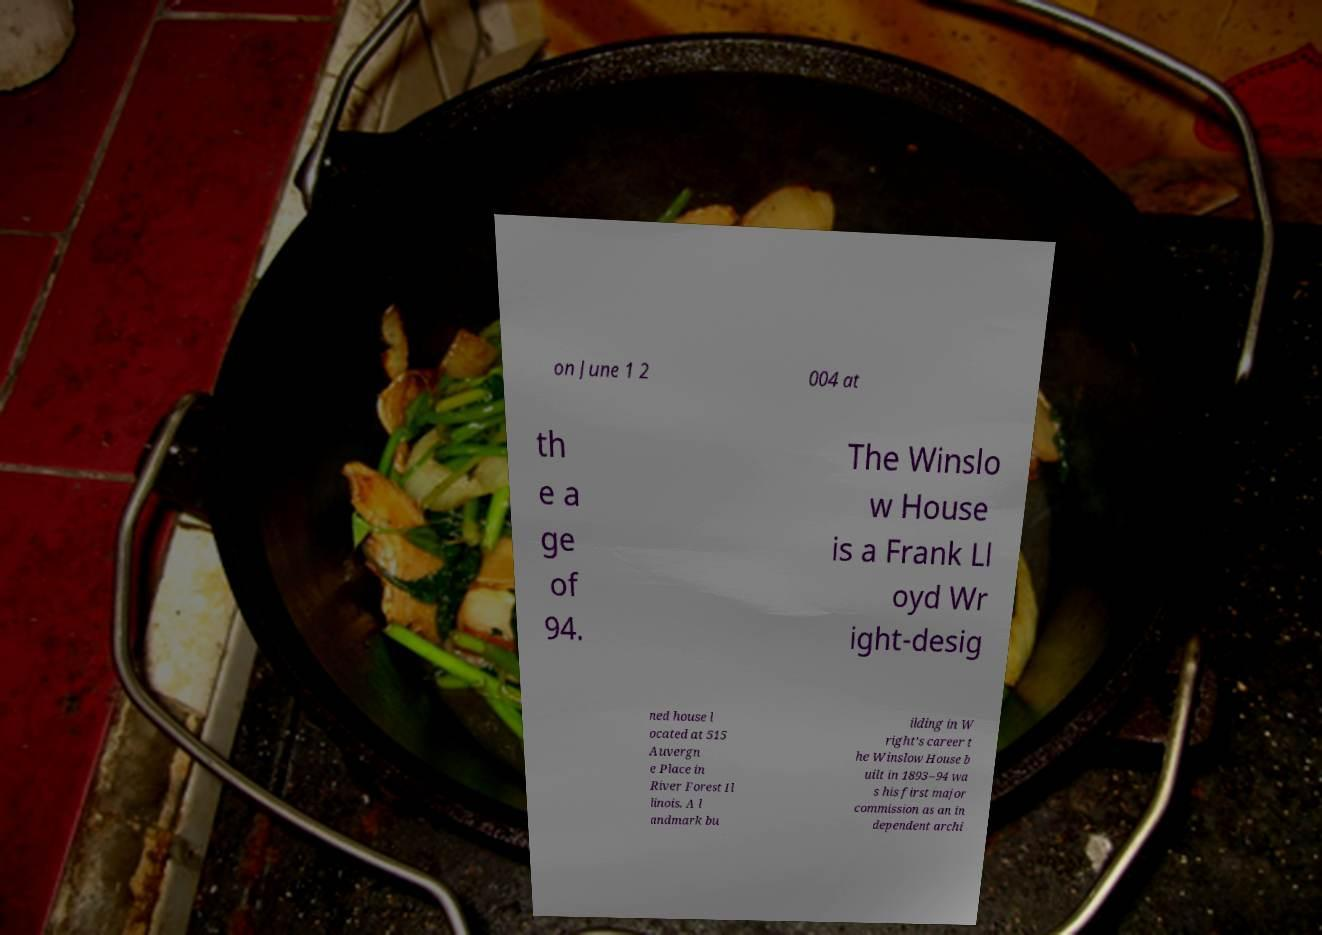For documentation purposes, I need the text within this image transcribed. Could you provide that? on June 1 2 004 at th e a ge of 94. The Winslo w House is a Frank Ll oyd Wr ight-desig ned house l ocated at 515 Auvergn e Place in River Forest Il linois. A l andmark bu ilding in W right's career t he Winslow House b uilt in 1893–94 wa s his first major commission as an in dependent archi 